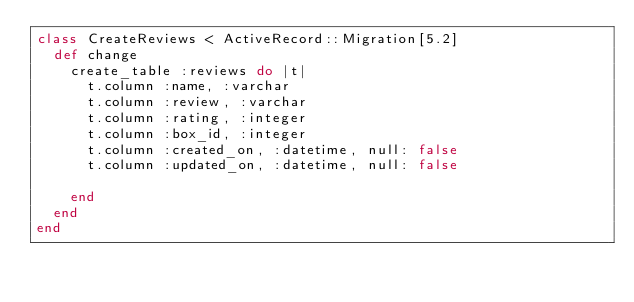<code> <loc_0><loc_0><loc_500><loc_500><_Ruby_>class CreateReviews < ActiveRecord::Migration[5.2]
  def change
    create_table :reviews do |t|
      t.column :name, :varchar
      t.column :review, :varchar
      t.column :rating, :integer
      t.column :box_id, :integer
      t.column :created_on, :datetime, null: false
      t.column :updated_on, :datetime, null: false

    end
  end
end
</code> 